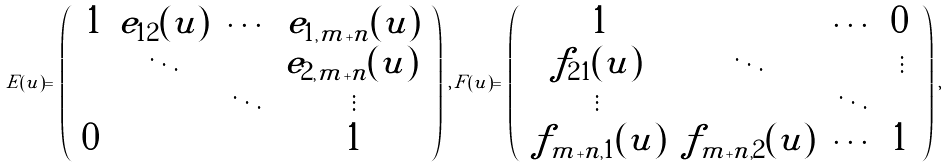<formula> <loc_0><loc_0><loc_500><loc_500>E ( u ) = \, \left ( \begin{array} { c c c c } \, 1 & e _ { 1 2 } ( u ) & \cdots & e _ { 1 , m + n } ( u ) \\ & \ddots & & e _ { 2 , m + n } ( u ) \, \\ & & \ddots & \vdots \\ 0 & & & 1 \end{array} \right ) \, , \, F ( u ) = \, \left ( \begin{array} { c c c c } \, 1 & & \cdots & 0 \, \\ f _ { 2 1 } ( u ) & \ddots & & \vdots \\ \vdots & & \ddots & \\ \, f _ { m + n , 1 } ( u ) & f _ { m + n , 2 } ( u ) & \cdots & 1 \, \end{array} \right ) \, ,</formula> 